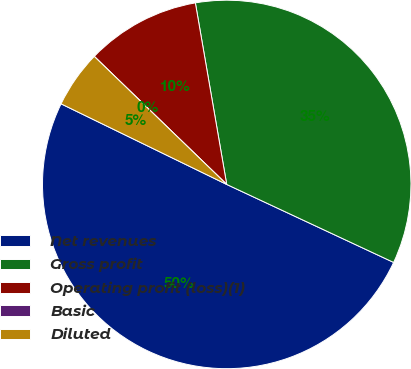Convert chart to OTSL. <chart><loc_0><loc_0><loc_500><loc_500><pie_chart><fcel>Net revenues<fcel>Gross profit<fcel>Operating profit (loss)(1)<fcel>Basic<fcel>Diluted<nl><fcel>50.25%<fcel>34.68%<fcel>10.05%<fcel>0.0%<fcel>5.02%<nl></chart> 